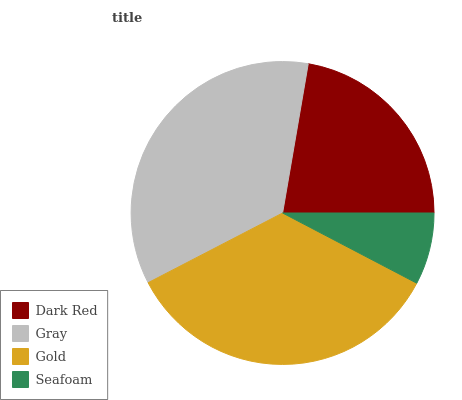Is Seafoam the minimum?
Answer yes or no. Yes. Is Gray the maximum?
Answer yes or no. Yes. Is Gold the minimum?
Answer yes or no. No. Is Gold the maximum?
Answer yes or no. No. Is Gray greater than Gold?
Answer yes or no. Yes. Is Gold less than Gray?
Answer yes or no. Yes. Is Gold greater than Gray?
Answer yes or no. No. Is Gray less than Gold?
Answer yes or no. No. Is Gold the high median?
Answer yes or no. Yes. Is Dark Red the low median?
Answer yes or no. Yes. Is Gray the high median?
Answer yes or no. No. Is Gold the low median?
Answer yes or no. No. 